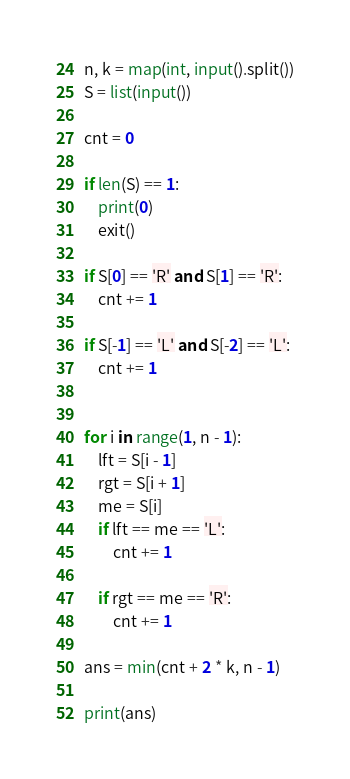<code> <loc_0><loc_0><loc_500><loc_500><_Python_>n, k = map(int, input().split())
S = list(input())

cnt = 0

if len(S) == 1:
    print(0)
    exit()

if S[0] == 'R' and S[1] == 'R':
    cnt += 1

if S[-1] == 'L' and S[-2] == 'L':
    cnt += 1


for i in range(1, n - 1):
    lft = S[i - 1]
    rgt = S[i + 1]
    me = S[i]
    if lft == me == 'L':
        cnt += 1

    if rgt == me == 'R':
        cnt += 1

ans = min(cnt + 2 * k, n - 1)

print(ans)
</code> 